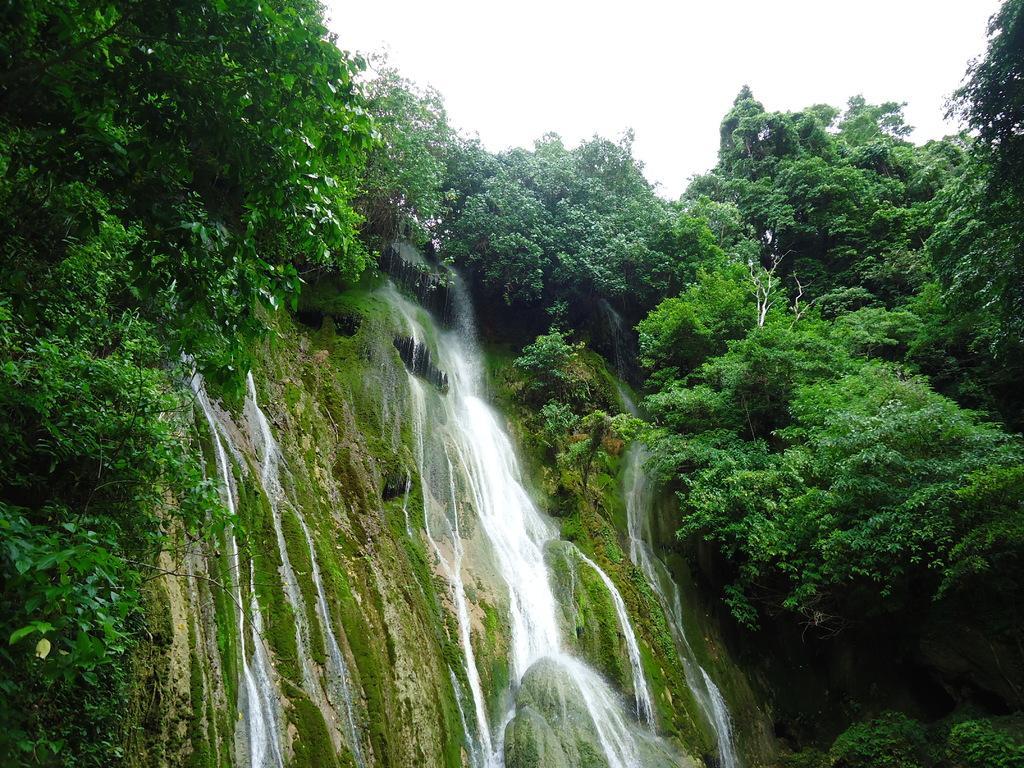Please provide a concise description of this image. Here we see the water flowing from the top and we can see some trees on the side of it. 